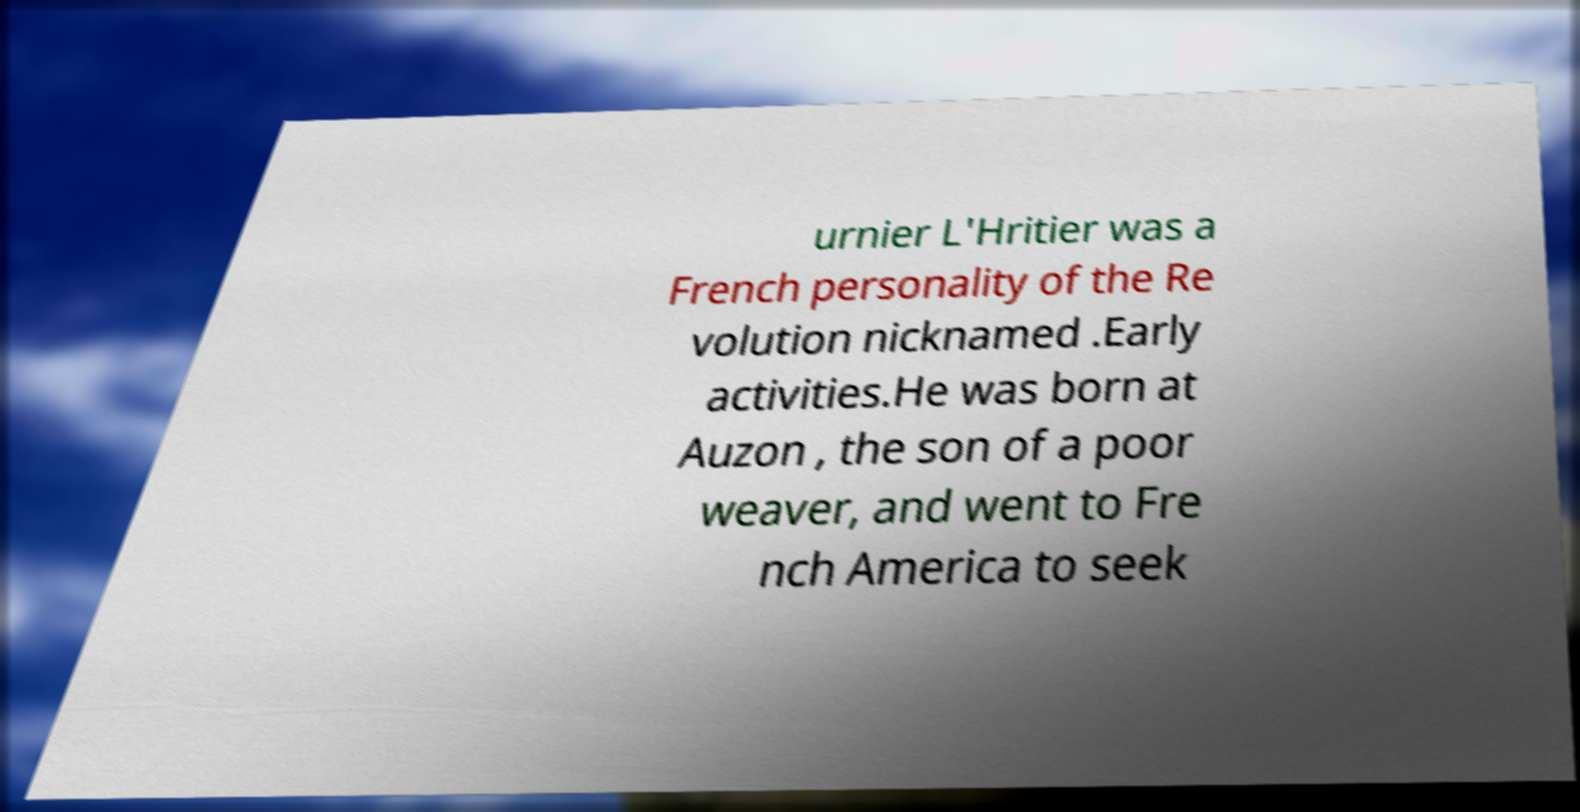I need the written content from this picture converted into text. Can you do that? urnier L'Hritier was a French personality of the Re volution nicknamed .Early activities.He was born at Auzon , the son of a poor weaver, and went to Fre nch America to seek 